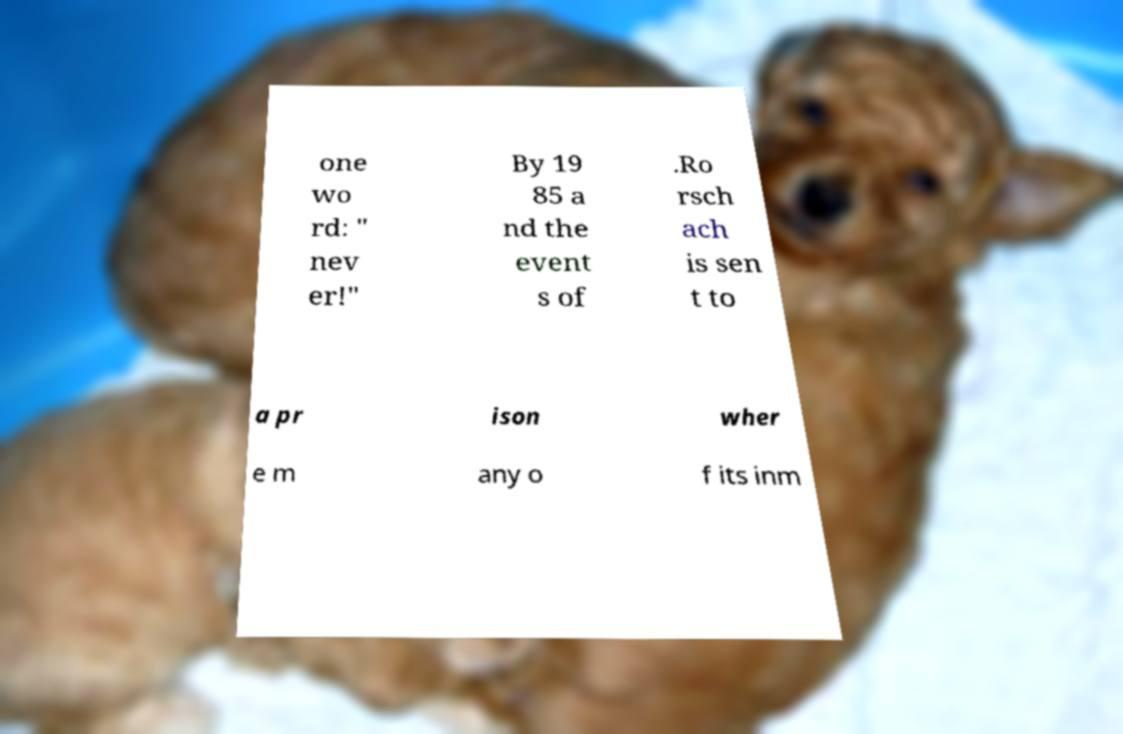Could you extract and type out the text from this image? one wo rd: " nev er!" By 19 85 a nd the event s of .Ro rsch ach is sen t to a pr ison wher e m any o f its inm 